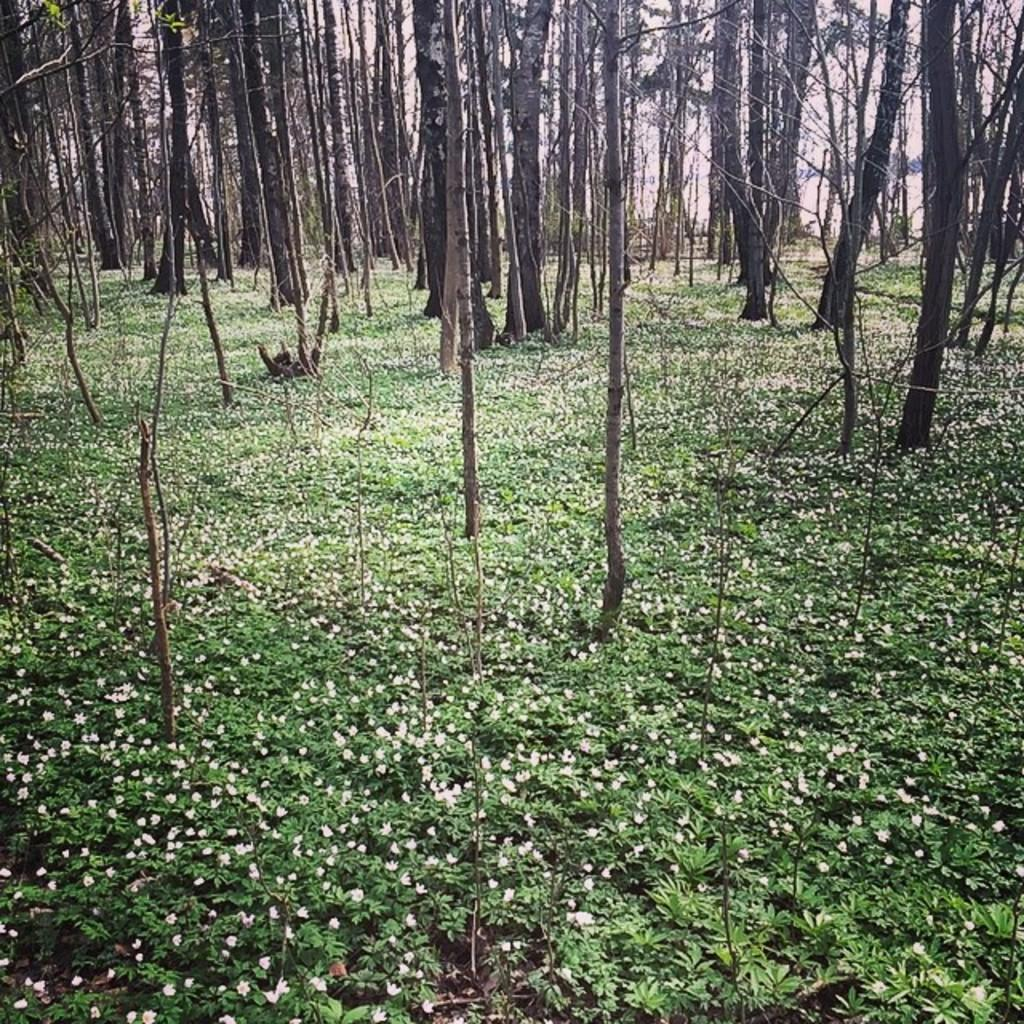What types of vegetation can be seen in the foreground of the image? There are plants and flowers in the foreground of the image. What types of trees are visible in the background of the image? There are trees in the background of the image. What type of hen can be seen in the image? There is no hen present in the image; it features plants, flowers, and trees. 